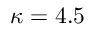Convert formula to latex. <formula><loc_0><loc_0><loc_500><loc_500>\kappa = 4 . 5</formula> 